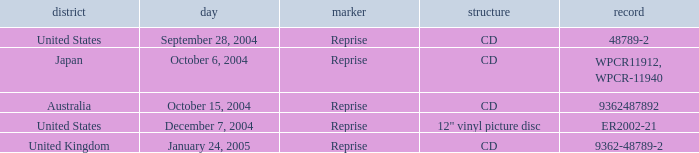Name the region for december 7, 2004 United States. 